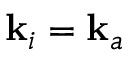<formula> <loc_0><loc_0><loc_500><loc_500>k _ { i } = k _ { a }</formula> 